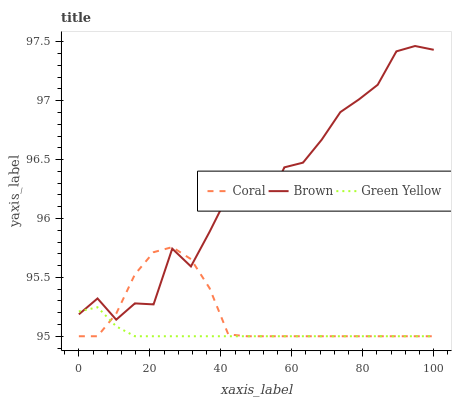Does Green Yellow have the minimum area under the curve?
Answer yes or no. Yes. Does Brown have the maximum area under the curve?
Answer yes or no. Yes. Does Coral have the minimum area under the curve?
Answer yes or no. No. Does Coral have the maximum area under the curve?
Answer yes or no. No. Is Green Yellow the smoothest?
Answer yes or no. Yes. Is Brown the roughest?
Answer yes or no. Yes. Is Coral the smoothest?
Answer yes or no. No. Is Coral the roughest?
Answer yes or no. No. Does Coral have the lowest value?
Answer yes or no. Yes. Does Brown have the highest value?
Answer yes or no. Yes. Does Coral have the highest value?
Answer yes or no. No. Does Green Yellow intersect Coral?
Answer yes or no. Yes. Is Green Yellow less than Coral?
Answer yes or no. No. Is Green Yellow greater than Coral?
Answer yes or no. No. 